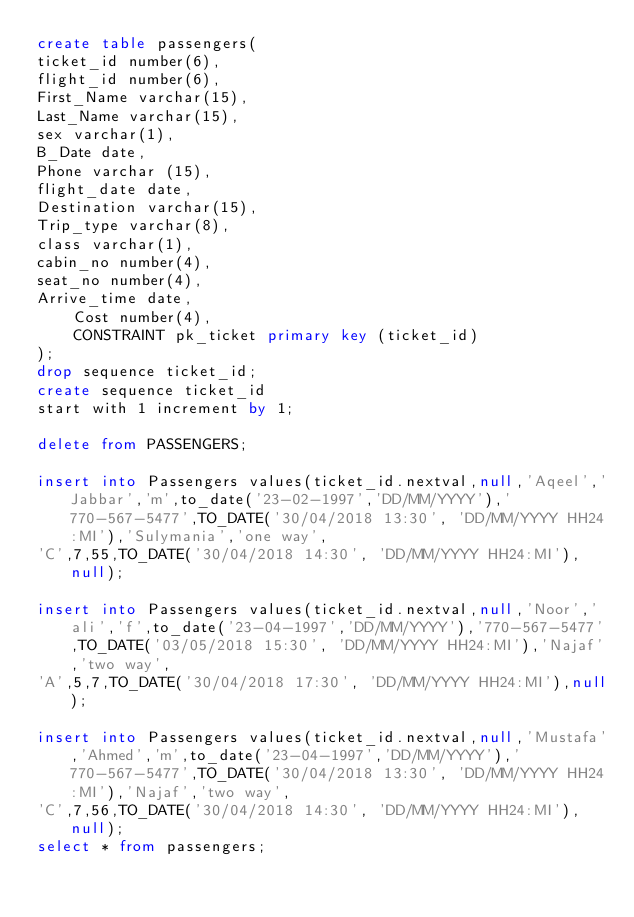Convert code to text. <code><loc_0><loc_0><loc_500><loc_500><_SQL_>create table passengers(
ticket_id number(6),
flight_id number(6),
First_Name varchar(15),
Last_Name varchar(15),
sex varchar(1),
B_Date date,
Phone varchar (15),
flight_date date,
Destination varchar(15),
Trip_type varchar(8),
class varchar(1),
cabin_no number(4),
seat_no number(4),
Arrive_time date,
    Cost number(4),
    CONSTRAINT pk_ticket primary key (ticket_id)
);
drop sequence ticket_id;
create sequence ticket_id
start with 1 increment by 1;

delete from PASSENGERS;

insert into Passengers values(ticket_id.nextval,null,'Aqeel','Jabbar','m',to_date('23-02-1997','DD/MM/YYYY'),'770-567-5477',TO_DATE('30/04/2018 13:30', 'DD/MM/YYYY HH24:MI'),'Sulymania','one way',
'C',7,55,TO_DATE('30/04/2018 14:30', 'DD/MM/YYYY HH24:MI'),null);

insert into Passengers values(ticket_id.nextval,null,'Noor','ali','f',to_date('23-04-1997','DD/MM/YYYY'),'770-567-5477',TO_DATE('03/05/2018 15:30', 'DD/MM/YYYY HH24:MI'),'Najaf','two way',
'A',5,7,TO_DATE('30/04/2018 17:30', 'DD/MM/YYYY HH24:MI'),null);

insert into Passengers values(ticket_id.nextval,null,'Mustafa','Ahmed','m',to_date('23-04-1997','DD/MM/YYYY'),'770-567-5477',TO_DATE('30/04/2018 13:30', 'DD/MM/YYYY HH24:MI'),'Najaf','two way',
'C',7,56,TO_DATE('30/04/2018 14:30', 'DD/MM/YYYY HH24:MI'),null);
select * from passengers;










</code> 